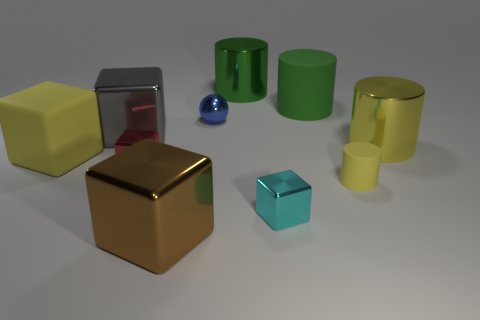What number of other objects are the same material as the brown block?
Your answer should be very brief. 6. Does the cyan object have the same shape as the yellow matte object behind the tiny cylinder?
Give a very brief answer. Yes. The brown object that is made of the same material as the small cyan cube is what shape?
Your answer should be compact. Cube. Is the number of metallic things on the right side of the red metal object greater than the number of metal objects in front of the blue metallic object?
Your response must be concise. No. What number of things are either cyan objects or big objects?
Your answer should be very brief. 7. What number of other objects are there of the same color as the tiny ball?
Give a very brief answer. 0. There is a yellow rubber object that is the same size as the brown metal thing; what is its shape?
Make the answer very short. Cube. There is a big matte thing behind the yellow rubber block; what color is it?
Your response must be concise. Green. What number of things are small metallic cubes that are in front of the small red shiny object or large things on the right side of the big green shiny object?
Your answer should be very brief. 3. Is the brown metallic object the same size as the blue metal object?
Offer a terse response. No. 